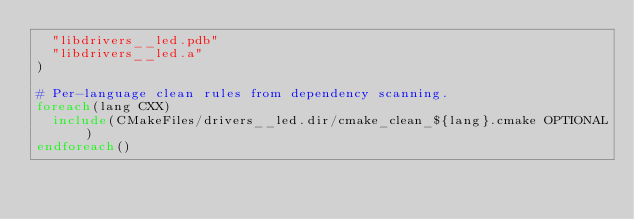Convert code to text. <code><loc_0><loc_0><loc_500><loc_500><_CMake_>  "libdrivers__led.pdb"
  "libdrivers__led.a"
)

# Per-language clean rules from dependency scanning.
foreach(lang CXX)
  include(CMakeFiles/drivers__led.dir/cmake_clean_${lang}.cmake OPTIONAL)
endforeach()
</code> 